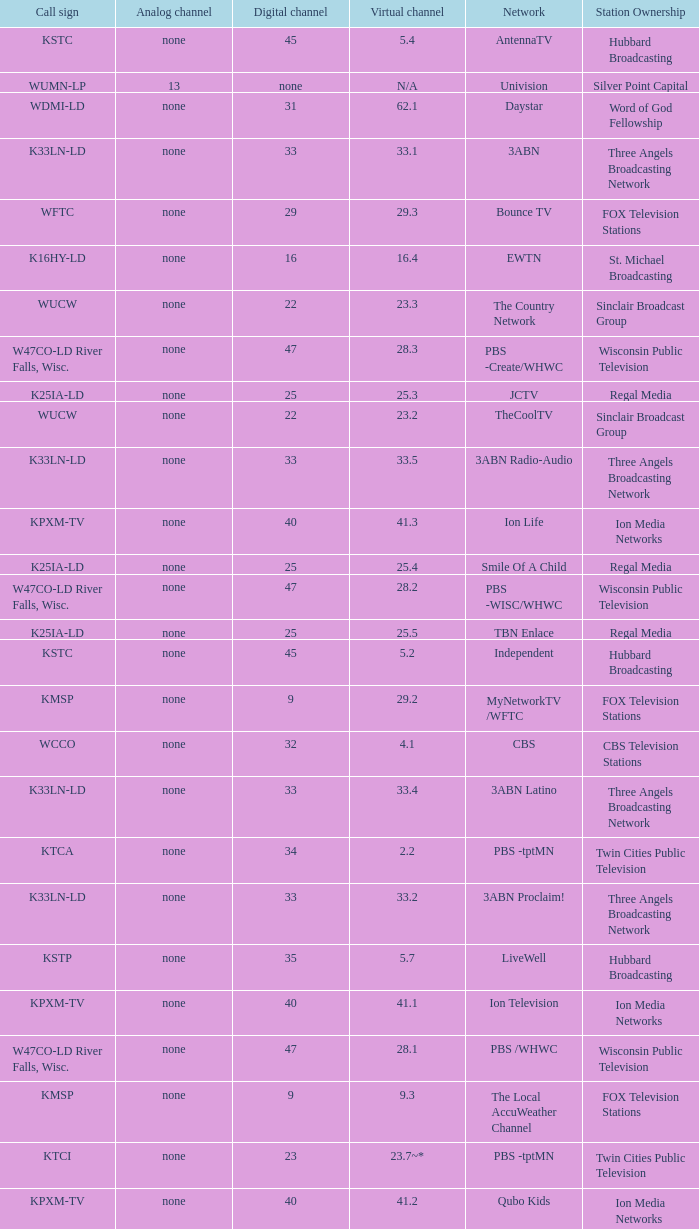Digital channel of 32 belongs to what analog channel? None. 